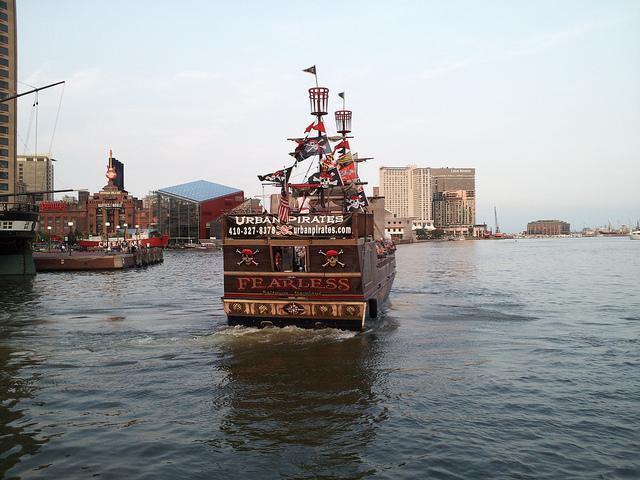How many boats are there?
Give a very brief answer. 1. 